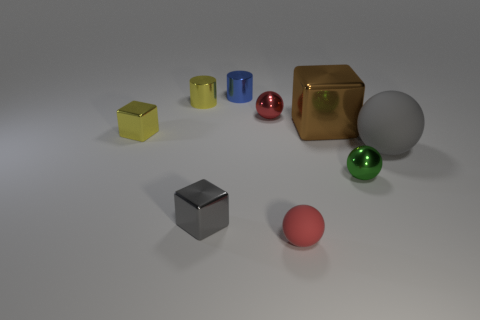There is another thing that is the same color as the large matte thing; what is its size?
Your answer should be very brief. Small. Is the material of the large thing that is on the left side of the gray rubber sphere the same as the red object that is to the left of the small red rubber sphere?
Ensure brevity in your answer.  Yes. What is the shape of the gray object that is on the left side of the small cylinder to the right of the tiny yellow shiny object that is to the right of the small yellow shiny block?
Make the answer very short. Cube. Are there more red objects than big matte balls?
Ensure brevity in your answer.  Yes. Are there any large brown rubber spheres?
Provide a succinct answer. No. How many things are either balls that are right of the large brown metal thing or small metal objects right of the small red shiny ball?
Offer a very short reply. 2. Does the large rubber sphere have the same color as the tiny matte ball?
Provide a succinct answer. No. Are there fewer large red rubber things than large brown metallic cubes?
Your answer should be very brief. Yes. There is a gray matte object; are there any small gray metal objects on the right side of it?
Provide a short and direct response. No. Are the gray block and the tiny yellow block made of the same material?
Your answer should be compact. Yes. 